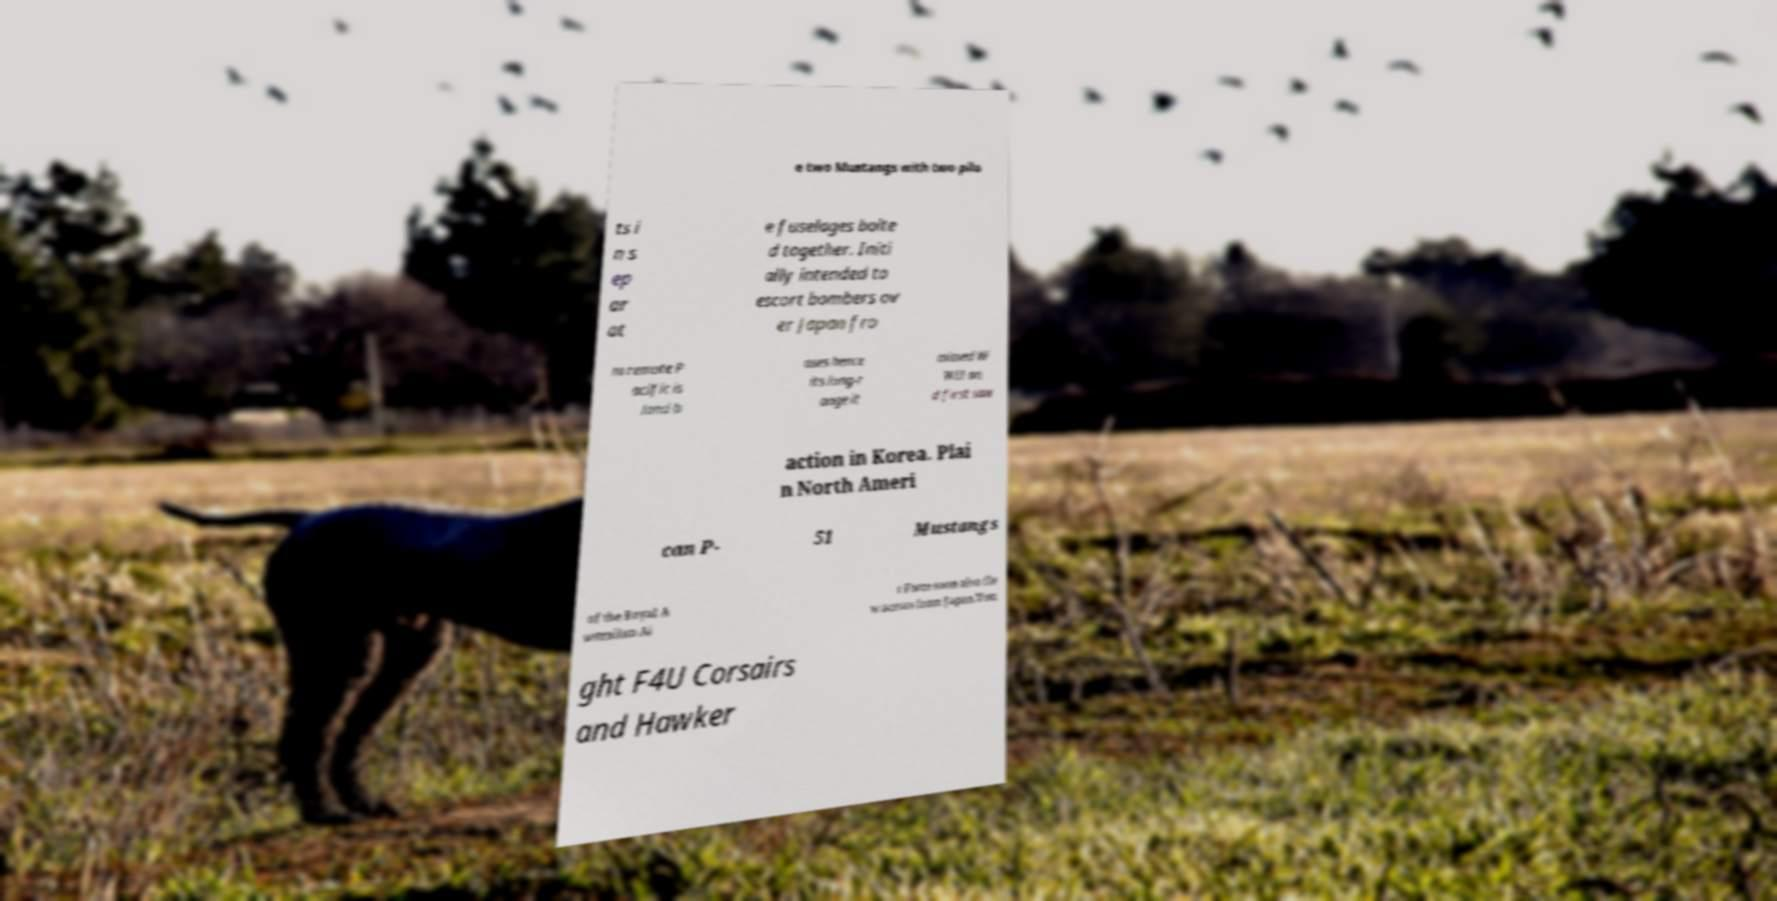For documentation purposes, I need the text within this image transcribed. Could you provide that? e two Mustangs with two pilo ts i n s ep ar at e fuselages bolte d together. Initi ally intended to escort bombers ov er Japan fro m remote P acific is land b ases hence its long-r ange it missed W WII an d first saw action in Korea. Plai n North Ameri can P- 51 Mustangs of the Royal A ustralian Ai r Force soon also fle w across from Japan.Vou ght F4U Corsairs and Hawker 